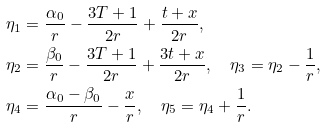Convert formula to latex. <formula><loc_0><loc_0><loc_500><loc_500>\eta _ { 1 } & = \frac { \alpha _ { 0 } } { r } - \frac { 3 T + 1 } { 2 r } + \frac { t + x } { 2 r } , \\ \eta _ { 2 } & = \frac { \beta _ { 0 } } { r } - \frac { 3 T + 1 } { 2 r } + \frac { 3 t + x } { 2 r } , \quad \eta _ { 3 } = \eta _ { 2 } - \frac { 1 } { r } , \\ \eta _ { 4 } & = \frac { \alpha _ { 0 } - \beta _ { 0 } } { r } - \frac { x } { r } , \quad \eta _ { 5 } = \eta _ { 4 } + \frac { 1 } { r } .</formula> 